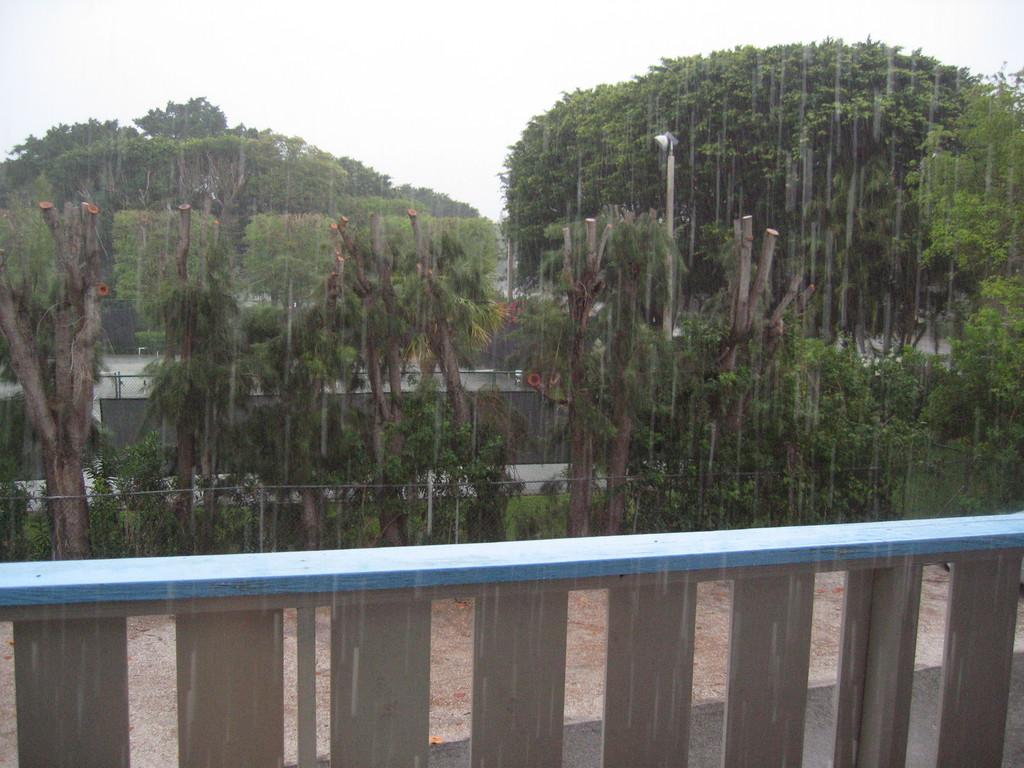What type of natural vegetation is visible in the image? There are trees in the image. What type of man-made structures can be seen in the image? There are roads and a light pole visible in the image. What type of barrier is present in the image? There is fencing in the image. What type of appliance is hanging from the trees in the image? There is no appliance hanging from the trees in the image; only trees, roads, a light pole, and fencing are present. What type of wool is visible on the roads in the image? There is no wool visible on the roads in the image; only trees, roads, a light pole, and fencing are present. 